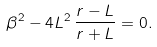Convert formula to latex. <formula><loc_0><loc_0><loc_500><loc_500>\beta ^ { 2 } - 4 L ^ { 2 } \, \frac { r - L } { r + L } = 0 .</formula> 